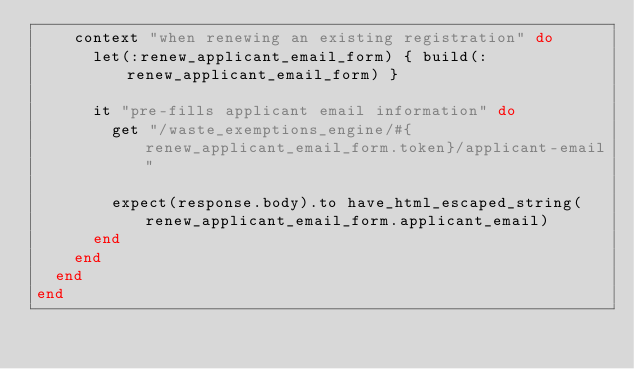<code> <loc_0><loc_0><loc_500><loc_500><_Ruby_>    context "when renewing an existing registration" do
      let(:renew_applicant_email_form) { build(:renew_applicant_email_form) }

      it "pre-fills applicant email information" do
        get "/waste_exemptions_engine/#{renew_applicant_email_form.token}/applicant-email"

        expect(response.body).to have_html_escaped_string(renew_applicant_email_form.applicant_email)
      end
    end
  end
end
</code> 